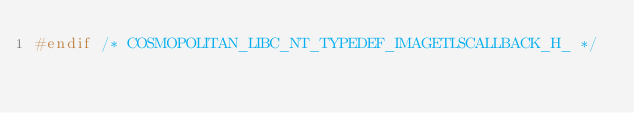Convert code to text. <code><loc_0><loc_0><loc_500><loc_500><_C_>#endif /* COSMOPOLITAN_LIBC_NT_TYPEDEF_IMAGETLSCALLBACK_H_ */
</code> 